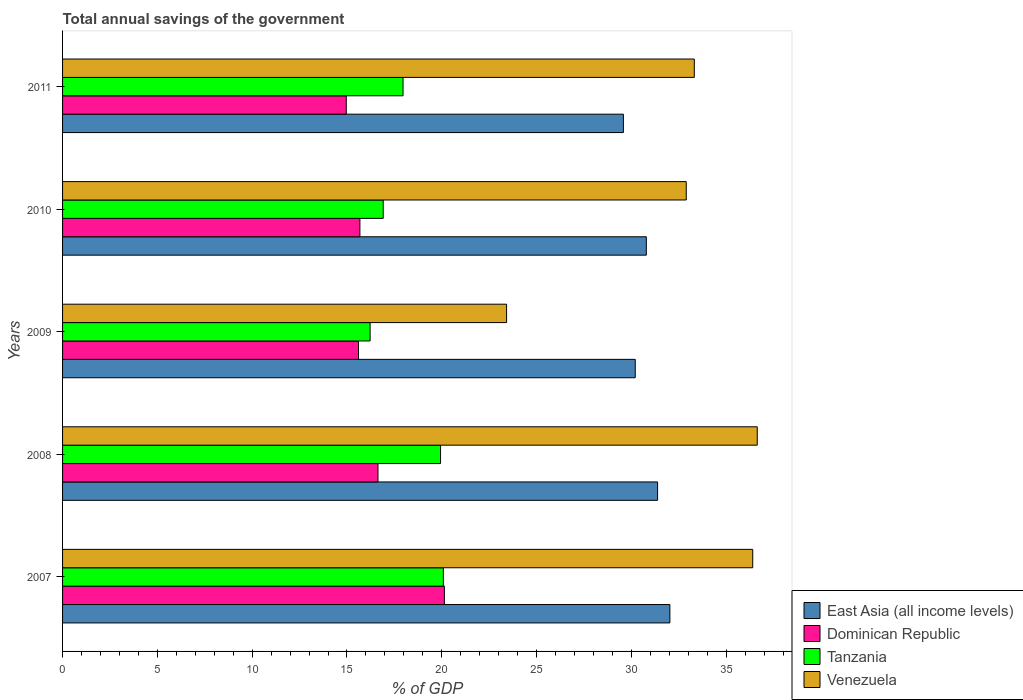How many different coloured bars are there?
Provide a succinct answer. 4. How many groups of bars are there?
Give a very brief answer. 5. Are the number of bars per tick equal to the number of legend labels?
Offer a very short reply. Yes. Are the number of bars on each tick of the Y-axis equal?
Your response must be concise. Yes. How many bars are there on the 3rd tick from the top?
Provide a succinct answer. 4. How many bars are there on the 3rd tick from the bottom?
Offer a terse response. 4. What is the total annual savings of the government in Venezuela in 2011?
Make the answer very short. 33.32. Across all years, what is the maximum total annual savings of the government in Venezuela?
Provide a short and direct response. 36.64. Across all years, what is the minimum total annual savings of the government in Venezuela?
Offer a very short reply. 23.42. In which year was the total annual savings of the government in Tanzania minimum?
Give a very brief answer. 2009. What is the total total annual savings of the government in Dominican Republic in the graph?
Make the answer very short. 83.03. What is the difference between the total annual savings of the government in Tanzania in 2007 and that in 2008?
Your answer should be compact. 0.15. What is the difference between the total annual savings of the government in Dominican Republic in 2010 and the total annual savings of the government in Tanzania in 2011?
Make the answer very short. -2.28. What is the average total annual savings of the government in Dominican Republic per year?
Make the answer very short. 16.61. In the year 2011, what is the difference between the total annual savings of the government in East Asia (all income levels) and total annual savings of the government in Dominican Republic?
Ensure brevity in your answer.  14.62. What is the ratio of the total annual savings of the government in Dominican Republic in 2008 to that in 2011?
Your answer should be very brief. 1.11. Is the difference between the total annual savings of the government in East Asia (all income levels) in 2007 and 2010 greater than the difference between the total annual savings of the government in Dominican Republic in 2007 and 2010?
Make the answer very short. No. What is the difference between the highest and the second highest total annual savings of the government in Venezuela?
Provide a short and direct response. 0.24. What is the difference between the highest and the lowest total annual savings of the government in Dominican Republic?
Offer a very short reply. 5.17. In how many years, is the total annual savings of the government in Tanzania greater than the average total annual savings of the government in Tanzania taken over all years?
Give a very brief answer. 2. Is it the case that in every year, the sum of the total annual savings of the government in Tanzania and total annual savings of the government in Dominican Republic is greater than the sum of total annual savings of the government in East Asia (all income levels) and total annual savings of the government in Venezuela?
Provide a succinct answer. No. What does the 2nd bar from the top in 2009 represents?
Offer a very short reply. Tanzania. What does the 2nd bar from the bottom in 2007 represents?
Offer a very short reply. Dominican Republic. Is it the case that in every year, the sum of the total annual savings of the government in East Asia (all income levels) and total annual savings of the government in Venezuela is greater than the total annual savings of the government in Dominican Republic?
Provide a short and direct response. Yes. Are all the bars in the graph horizontal?
Make the answer very short. Yes. What is the difference between two consecutive major ticks on the X-axis?
Your answer should be compact. 5. Are the values on the major ticks of X-axis written in scientific E-notation?
Provide a succinct answer. No. Where does the legend appear in the graph?
Give a very brief answer. Bottom right. What is the title of the graph?
Offer a very short reply. Total annual savings of the government. Does "Belize" appear as one of the legend labels in the graph?
Offer a terse response. No. What is the label or title of the X-axis?
Keep it short and to the point. % of GDP. What is the % of GDP in East Asia (all income levels) in 2007?
Offer a very short reply. 32.03. What is the % of GDP in Dominican Republic in 2007?
Your answer should be compact. 20.14. What is the % of GDP in Tanzania in 2007?
Your answer should be very brief. 20.08. What is the % of GDP of Venezuela in 2007?
Offer a terse response. 36.4. What is the % of GDP in East Asia (all income levels) in 2008?
Your answer should be very brief. 31.38. What is the % of GDP in Dominican Republic in 2008?
Provide a succinct answer. 16.64. What is the % of GDP in Tanzania in 2008?
Keep it short and to the point. 19.94. What is the % of GDP of Venezuela in 2008?
Your response must be concise. 36.64. What is the % of GDP in East Asia (all income levels) in 2009?
Keep it short and to the point. 30.21. What is the % of GDP in Dominican Republic in 2009?
Provide a short and direct response. 15.61. What is the % of GDP in Tanzania in 2009?
Your answer should be compact. 16.22. What is the % of GDP of Venezuela in 2009?
Your response must be concise. 23.42. What is the % of GDP in East Asia (all income levels) in 2010?
Provide a succinct answer. 30.79. What is the % of GDP of Dominican Republic in 2010?
Keep it short and to the point. 15.68. What is the % of GDP of Tanzania in 2010?
Ensure brevity in your answer.  16.91. What is the % of GDP of Venezuela in 2010?
Your answer should be very brief. 32.9. What is the % of GDP of East Asia (all income levels) in 2011?
Offer a terse response. 29.58. What is the % of GDP of Dominican Republic in 2011?
Offer a very short reply. 14.96. What is the % of GDP in Tanzania in 2011?
Keep it short and to the point. 17.96. What is the % of GDP of Venezuela in 2011?
Offer a very short reply. 33.32. Across all years, what is the maximum % of GDP in East Asia (all income levels)?
Offer a very short reply. 32.03. Across all years, what is the maximum % of GDP of Dominican Republic?
Offer a terse response. 20.14. Across all years, what is the maximum % of GDP in Tanzania?
Keep it short and to the point. 20.08. Across all years, what is the maximum % of GDP in Venezuela?
Your answer should be compact. 36.64. Across all years, what is the minimum % of GDP in East Asia (all income levels)?
Offer a very short reply. 29.58. Across all years, what is the minimum % of GDP of Dominican Republic?
Your answer should be compact. 14.96. Across all years, what is the minimum % of GDP of Tanzania?
Your response must be concise. 16.22. Across all years, what is the minimum % of GDP of Venezuela?
Provide a short and direct response. 23.42. What is the total % of GDP of East Asia (all income levels) in the graph?
Keep it short and to the point. 153.99. What is the total % of GDP in Dominican Republic in the graph?
Keep it short and to the point. 83.03. What is the total % of GDP in Tanzania in the graph?
Your answer should be very brief. 91.11. What is the total % of GDP of Venezuela in the graph?
Offer a terse response. 162.68. What is the difference between the % of GDP in East Asia (all income levels) in 2007 and that in 2008?
Your response must be concise. 0.65. What is the difference between the % of GDP in Dominican Republic in 2007 and that in 2008?
Provide a short and direct response. 3.5. What is the difference between the % of GDP of Tanzania in 2007 and that in 2008?
Provide a succinct answer. 0.15. What is the difference between the % of GDP of Venezuela in 2007 and that in 2008?
Offer a terse response. -0.24. What is the difference between the % of GDP in East Asia (all income levels) in 2007 and that in 2009?
Provide a succinct answer. 1.83. What is the difference between the % of GDP of Dominican Republic in 2007 and that in 2009?
Your response must be concise. 4.53. What is the difference between the % of GDP of Tanzania in 2007 and that in 2009?
Ensure brevity in your answer.  3.86. What is the difference between the % of GDP of Venezuela in 2007 and that in 2009?
Ensure brevity in your answer.  12.98. What is the difference between the % of GDP in East Asia (all income levels) in 2007 and that in 2010?
Keep it short and to the point. 1.24. What is the difference between the % of GDP of Dominican Republic in 2007 and that in 2010?
Keep it short and to the point. 4.46. What is the difference between the % of GDP of Tanzania in 2007 and that in 2010?
Your answer should be compact. 3.17. What is the difference between the % of GDP of Venezuela in 2007 and that in 2010?
Provide a short and direct response. 3.51. What is the difference between the % of GDP in East Asia (all income levels) in 2007 and that in 2011?
Make the answer very short. 2.45. What is the difference between the % of GDP of Dominican Republic in 2007 and that in 2011?
Make the answer very short. 5.17. What is the difference between the % of GDP of Tanzania in 2007 and that in 2011?
Provide a succinct answer. 2.13. What is the difference between the % of GDP of Venezuela in 2007 and that in 2011?
Your response must be concise. 3.08. What is the difference between the % of GDP in East Asia (all income levels) in 2008 and that in 2009?
Offer a very short reply. 1.18. What is the difference between the % of GDP of Dominican Republic in 2008 and that in 2009?
Provide a short and direct response. 1.03. What is the difference between the % of GDP in Tanzania in 2008 and that in 2009?
Keep it short and to the point. 3.71. What is the difference between the % of GDP in Venezuela in 2008 and that in 2009?
Your answer should be compact. 13.22. What is the difference between the % of GDP of East Asia (all income levels) in 2008 and that in 2010?
Make the answer very short. 0.59. What is the difference between the % of GDP of Dominican Republic in 2008 and that in 2010?
Give a very brief answer. 0.95. What is the difference between the % of GDP in Tanzania in 2008 and that in 2010?
Your answer should be very brief. 3.02. What is the difference between the % of GDP of Venezuela in 2008 and that in 2010?
Offer a terse response. 3.74. What is the difference between the % of GDP in East Asia (all income levels) in 2008 and that in 2011?
Make the answer very short. 1.8. What is the difference between the % of GDP of Dominican Republic in 2008 and that in 2011?
Offer a very short reply. 1.67. What is the difference between the % of GDP in Tanzania in 2008 and that in 2011?
Your response must be concise. 1.98. What is the difference between the % of GDP in Venezuela in 2008 and that in 2011?
Ensure brevity in your answer.  3.32. What is the difference between the % of GDP in East Asia (all income levels) in 2009 and that in 2010?
Offer a very short reply. -0.58. What is the difference between the % of GDP in Dominican Republic in 2009 and that in 2010?
Ensure brevity in your answer.  -0.07. What is the difference between the % of GDP in Tanzania in 2009 and that in 2010?
Provide a succinct answer. -0.69. What is the difference between the % of GDP of Venezuela in 2009 and that in 2010?
Your answer should be very brief. -9.48. What is the difference between the % of GDP in East Asia (all income levels) in 2009 and that in 2011?
Provide a short and direct response. 0.62. What is the difference between the % of GDP of Dominican Republic in 2009 and that in 2011?
Offer a terse response. 0.64. What is the difference between the % of GDP of Tanzania in 2009 and that in 2011?
Your answer should be compact. -1.74. What is the difference between the % of GDP of Venezuela in 2009 and that in 2011?
Offer a very short reply. -9.9. What is the difference between the % of GDP in East Asia (all income levels) in 2010 and that in 2011?
Your response must be concise. 1.21. What is the difference between the % of GDP of Dominican Republic in 2010 and that in 2011?
Offer a terse response. 0.72. What is the difference between the % of GDP in Tanzania in 2010 and that in 2011?
Provide a succinct answer. -1.05. What is the difference between the % of GDP in Venezuela in 2010 and that in 2011?
Offer a very short reply. -0.42. What is the difference between the % of GDP in East Asia (all income levels) in 2007 and the % of GDP in Dominican Republic in 2008?
Offer a very short reply. 15.4. What is the difference between the % of GDP in East Asia (all income levels) in 2007 and the % of GDP in Tanzania in 2008?
Offer a very short reply. 12.1. What is the difference between the % of GDP of East Asia (all income levels) in 2007 and the % of GDP of Venezuela in 2008?
Provide a succinct answer. -4.61. What is the difference between the % of GDP in Dominican Republic in 2007 and the % of GDP in Tanzania in 2008?
Ensure brevity in your answer.  0.2. What is the difference between the % of GDP in Dominican Republic in 2007 and the % of GDP in Venezuela in 2008?
Provide a short and direct response. -16.5. What is the difference between the % of GDP of Tanzania in 2007 and the % of GDP of Venezuela in 2008?
Offer a terse response. -16.56. What is the difference between the % of GDP in East Asia (all income levels) in 2007 and the % of GDP in Dominican Republic in 2009?
Offer a very short reply. 16.42. What is the difference between the % of GDP in East Asia (all income levels) in 2007 and the % of GDP in Tanzania in 2009?
Ensure brevity in your answer.  15.81. What is the difference between the % of GDP of East Asia (all income levels) in 2007 and the % of GDP of Venezuela in 2009?
Ensure brevity in your answer.  8.61. What is the difference between the % of GDP in Dominican Republic in 2007 and the % of GDP in Tanzania in 2009?
Keep it short and to the point. 3.92. What is the difference between the % of GDP in Dominican Republic in 2007 and the % of GDP in Venezuela in 2009?
Your answer should be very brief. -3.28. What is the difference between the % of GDP of Tanzania in 2007 and the % of GDP of Venezuela in 2009?
Your response must be concise. -3.33. What is the difference between the % of GDP of East Asia (all income levels) in 2007 and the % of GDP of Dominican Republic in 2010?
Ensure brevity in your answer.  16.35. What is the difference between the % of GDP of East Asia (all income levels) in 2007 and the % of GDP of Tanzania in 2010?
Offer a terse response. 15.12. What is the difference between the % of GDP in East Asia (all income levels) in 2007 and the % of GDP in Venezuela in 2010?
Your answer should be compact. -0.86. What is the difference between the % of GDP of Dominican Republic in 2007 and the % of GDP of Tanzania in 2010?
Make the answer very short. 3.23. What is the difference between the % of GDP in Dominican Republic in 2007 and the % of GDP in Venezuela in 2010?
Offer a terse response. -12.76. What is the difference between the % of GDP of Tanzania in 2007 and the % of GDP of Venezuela in 2010?
Your answer should be very brief. -12.81. What is the difference between the % of GDP of East Asia (all income levels) in 2007 and the % of GDP of Dominican Republic in 2011?
Provide a succinct answer. 17.07. What is the difference between the % of GDP of East Asia (all income levels) in 2007 and the % of GDP of Tanzania in 2011?
Keep it short and to the point. 14.07. What is the difference between the % of GDP of East Asia (all income levels) in 2007 and the % of GDP of Venezuela in 2011?
Your response must be concise. -1.29. What is the difference between the % of GDP in Dominican Republic in 2007 and the % of GDP in Tanzania in 2011?
Offer a very short reply. 2.18. What is the difference between the % of GDP in Dominican Republic in 2007 and the % of GDP in Venezuela in 2011?
Make the answer very short. -13.18. What is the difference between the % of GDP in Tanzania in 2007 and the % of GDP in Venezuela in 2011?
Give a very brief answer. -13.24. What is the difference between the % of GDP in East Asia (all income levels) in 2008 and the % of GDP in Dominican Republic in 2009?
Offer a terse response. 15.78. What is the difference between the % of GDP in East Asia (all income levels) in 2008 and the % of GDP in Tanzania in 2009?
Ensure brevity in your answer.  15.16. What is the difference between the % of GDP in East Asia (all income levels) in 2008 and the % of GDP in Venezuela in 2009?
Your response must be concise. 7.96. What is the difference between the % of GDP in Dominican Republic in 2008 and the % of GDP in Tanzania in 2009?
Your response must be concise. 0.42. What is the difference between the % of GDP of Dominican Republic in 2008 and the % of GDP of Venezuela in 2009?
Your answer should be very brief. -6.78. What is the difference between the % of GDP of Tanzania in 2008 and the % of GDP of Venezuela in 2009?
Ensure brevity in your answer.  -3.48. What is the difference between the % of GDP in East Asia (all income levels) in 2008 and the % of GDP in Dominican Republic in 2010?
Offer a terse response. 15.7. What is the difference between the % of GDP in East Asia (all income levels) in 2008 and the % of GDP in Tanzania in 2010?
Provide a succinct answer. 14.47. What is the difference between the % of GDP in East Asia (all income levels) in 2008 and the % of GDP in Venezuela in 2010?
Ensure brevity in your answer.  -1.51. What is the difference between the % of GDP of Dominican Republic in 2008 and the % of GDP of Tanzania in 2010?
Ensure brevity in your answer.  -0.28. What is the difference between the % of GDP in Dominican Republic in 2008 and the % of GDP in Venezuela in 2010?
Your answer should be very brief. -16.26. What is the difference between the % of GDP of Tanzania in 2008 and the % of GDP of Venezuela in 2010?
Give a very brief answer. -12.96. What is the difference between the % of GDP of East Asia (all income levels) in 2008 and the % of GDP of Dominican Republic in 2011?
Give a very brief answer. 16.42. What is the difference between the % of GDP of East Asia (all income levels) in 2008 and the % of GDP of Tanzania in 2011?
Your answer should be compact. 13.42. What is the difference between the % of GDP in East Asia (all income levels) in 2008 and the % of GDP in Venezuela in 2011?
Keep it short and to the point. -1.94. What is the difference between the % of GDP of Dominican Republic in 2008 and the % of GDP of Tanzania in 2011?
Offer a very short reply. -1.32. What is the difference between the % of GDP in Dominican Republic in 2008 and the % of GDP in Venezuela in 2011?
Provide a succinct answer. -16.68. What is the difference between the % of GDP in Tanzania in 2008 and the % of GDP in Venezuela in 2011?
Your response must be concise. -13.38. What is the difference between the % of GDP in East Asia (all income levels) in 2009 and the % of GDP in Dominican Republic in 2010?
Your answer should be very brief. 14.52. What is the difference between the % of GDP of East Asia (all income levels) in 2009 and the % of GDP of Tanzania in 2010?
Your response must be concise. 13.29. What is the difference between the % of GDP in East Asia (all income levels) in 2009 and the % of GDP in Venezuela in 2010?
Provide a succinct answer. -2.69. What is the difference between the % of GDP in Dominican Republic in 2009 and the % of GDP in Tanzania in 2010?
Provide a succinct answer. -1.3. What is the difference between the % of GDP in Dominican Republic in 2009 and the % of GDP in Venezuela in 2010?
Give a very brief answer. -17.29. What is the difference between the % of GDP in Tanzania in 2009 and the % of GDP in Venezuela in 2010?
Offer a terse response. -16.67. What is the difference between the % of GDP in East Asia (all income levels) in 2009 and the % of GDP in Dominican Republic in 2011?
Your answer should be very brief. 15.24. What is the difference between the % of GDP in East Asia (all income levels) in 2009 and the % of GDP in Tanzania in 2011?
Your answer should be compact. 12.25. What is the difference between the % of GDP of East Asia (all income levels) in 2009 and the % of GDP of Venezuela in 2011?
Make the answer very short. -3.12. What is the difference between the % of GDP in Dominican Republic in 2009 and the % of GDP in Tanzania in 2011?
Ensure brevity in your answer.  -2.35. What is the difference between the % of GDP of Dominican Republic in 2009 and the % of GDP of Venezuela in 2011?
Provide a succinct answer. -17.71. What is the difference between the % of GDP of Tanzania in 2009 and the % of GDP of Venezuela in 2011?
Provide a short and direct response. -17.1. What is the difference between the % of GDP of East Asia (all income levels) in 2010 and the % of GDP of Dominican Republic in 2011?
Provide a short and direct response. 15.83. What is the difference between the % of GDP in East Asia (all income levels) in 2010 and the % of GDP in Tanzania in 2011?
Offer a terse response. 12.83. What is the difference between the % of GDP of East Asia (all income levels) in 2010 and the % of GDP of Venezuela in 2011?
Ensure brevity in your answer.  -2.53. What is the difference between the % of GDP of Dominican Republic in 2010 and the % of GDP of Tanzania in 2011?
Your response must be concise. -2.28. What is the difference between the % of GDP in Dominican Republic in 2010 and the % of GDP in Venezuela in 2011?
Make the answer very short. -17.64. What is the difference between the % of GDP in Tanzania in 2010 and the % of GDP in Venezuela in 2011?
Your answer should be very brief. -16.41. What is the average % of GDP of East Asia (all income levels) per year?
Make the answer very short. 30.8. What is the average % of GDP of Dominican Republic per year?
Offer a terse response. 16.61. What is the average % of GDP of Tanzania per year?
Keep it short and to the point. 18.22. What is the average % of GDP in Venezuela per year?
Your answer should be very brief. 32.54. In the year 2007, what is the difference between the % of GDP of East Asia (all income levels) and % of GDP of Dominican Republic?
Provide a succinct answer. 11.89. In the year 2007, what is the difference between the % of GDP of East Asia (all income levels) and % of GDP of Tanzania?
Offer a very short reply. 11.95. In the year 2007, what is the difference between the % of GDP in East Asia (all income levels) and % of GDP in Venezuela?
Give a very brief answer. -4.37. In the year 2007, what is the difference between the % of GDP in Dominican Republic and % of GDP in Tanzania?
Keep it short and to the point. 0.05. In the year 2007, what is the difference between the % of GDP in Dominican Republic and % of GDP in Venezuela?
Offer a terse response. -16.26. In the year 2007, what is the difference between the % of GDP of Tanzania and % of GDP of Venezuela?
Your answer should be very brief. -16.32. In the year 2008, what is the difference between the % of GDP of East Asia (all income levels) and % of GDP of Dominican Republic?
Offer a terse response. 14.75. In the year 2008, what is the difference between the % of GDP of East Asia (all income levels) and % of GDP of Tanzania?
Make the answer very short. 11.45. In the year 2008, what is the difference between the % of GDP of East Asia (all income levels) and % of GDP of Venezuela?
Your answer should be compact. -5.26. In the year 2008, what is the difference between the % of GDP of Dominican Republic and % of GDP of Tanzania?
Keep it short and to the point. -3.3. In the year 2008, what is the difference between the % of GDP of Dominican Republic and % of GDP of Venezuela?
Provide a succinct answer. -20. In the year 2008, what is the difference between the % of GDP in Tanzania and % of GDP in Venezuela?
Provide a short and direct response. -16.7. In the year 2009, what is the difference between the % of GDP of East Asia (all income levels) and % of GDP of Dominican Republic?
Your answer should be very brief. 14.6. In the year 2009, what is the difference between the % of GDP of East Asia (all income levels) and % of GDP of Tanzania?
Keep it short and to the point. 13.98. In the year 2009, what is the difference between the % of GDP of East Asia (all income levels) and % of GDP of Venezuela?
Your answer should be very brief. 6.79. In the year 2009, what is the difference between the % of GDP of Dominican Republic and % of GDP of Tanzania?
Keep it short and to the point. -0.61. In the year 2009, what is the difference between the % of GDP of Dominican Republic and % of GDP of Venezuela?
Ensure brevity in your answer.  -7.81. In the year 2009, what is the difference between the % of GDP in Tanzania and % of GDP in Venezuela?
Provide a short and direct response. -7.2. In the year 2010, what is the difference between the % of GDP in East Asia (all income levels) and % of GDP in Dominican Republic?
Your response must be concise. 15.11. In the year 2010, what is the difference between the % of GDP of East Asia (all income levels) and % of GDP of Tanzania?
Make the answer very short. 13.88. In the year 2010, what is the difference between the % of GDP of East Asia (all income levels) and % of GDP of Venezuela?
Your answer should be very brief. -2.11. In the year 2010, what is the difference between the % of GDP in Dominican Republic and % of GDP in Tanzania?
Ensure brevity in your answer.  -1.23. In the year 2010, what is the difference between the % of GDP of Dominican Republic and % of GDP of Venezuela?
Offer a very short reply. -17.21. In the year 2010, what is the difference between the % of GDP in Tanzania and % of GDP in Venezuela?
Provide a short and direct response. -15.98. In the year 2011, what is the difference between the % of GDP of East Asia (all income levels) and % of GDP of Dominican Republic?
Your answer should be compact. 14.62. In the year 2011, what is the difference between the % of GDP in East Asia (all income levels) and % of GDP in Tanzania?
Offer a terse response. 11.62. In the year 2011, what is the difference between the % of GDP of East Asia (all income levels) and % of GDP of Venezuela?
Make the answer very short. -3.74. In the year 2011, what is the difference between the % of GDP in Dominican Republic and % of GDP in Tanzania?
Your answer should be compact. -2.99. In the year 2011, what is the difference between the % of GDP in Dominican Republic and % of GDP in Venezuela?
Offer a very short reply. -18.36. In the year 2011, what is the difference between the % of GDP in Tanzania and % of GDP in Venezuela?
Keep it short and to the point. -15.36. What is the ratio of the % of GDP in East Asia (all income levels) in 2007 to that in 2008?
Provide a succinct answer. 1.02. What is the ratio of the % of GDP in Dominican Republic in 2007 to that in 2008?
Provide a short and direct response. 1.21. What is the ratio of the % of GDP in Tanzania in 2007 to that in 2008?
Keep it short and to the point. 1.01. What is the ratio of the % of GDP in Venezuela in 2007 to that in 2008?
Your answer should be very brief. 0.99. What is the ratio of the % of GDP in East Asia (all income levels) in 2007 to that in 2009?
Your response must be concise. 1.06. What is the ratio of the % of GDP in Dominican Republic in 2007 to that in 2009?
Give a very brief answer. 1.29. What is the ratio of the % of GDP of Tanzania in 2007 to that in 2009?
Provide a succinct answer. 1.24. What is the ratio of the % of GDP in Venezuela in 2007 to that in 2009?
Your response must be concise. 1.55. What is the ratio of the % of GDP in East Asia (all income levels) in 2007 to that in 2010?
Give a very brief answer. 1.04. What is the ratio of the % of GDP of Dominican Republic in 2007 to that in 2010?
Your response must be concise. 1.28. What is the ratio of the % of GDP in Tanzania in 2007 to that in 2010?
Your answer should be compact. 1.19. What is the ratio of the % of GDP in Venezuela in 2007 to that in 2010?
Give a very brief answer. 1.11. What is the ratio of the % of GDP in East Asia (all income levels) in 2007 to that in 2011?
Offer a very short reply. 1.08. What is the ratio of the % of GDP of Dominican Republic in 2007 to that in 2011?
Ensure brevity in your answer.  1.35. What is the ratio of the % of GDP of Tanzania in 2007 to that in 2011?
Provide a succinct answer. 1.12. What is the ratio of the % of GDP of Venezuela in 2007 to that in 2011?
Your answer should be compact. 1.09. What is the ratio of the % of GDP of East Asia (all income levels) in 2008 to that in 2009?
Provide a succinct answer. 1.04. What is the ratio of the % of GDP in Dominican Republic in 2008 to that in 2009?
Your answer should be compact. 1.07. What is the ratio of the % of GDP in Tanzania in 2008 to that in 2009?
Keep it short and to the point. 1.23. What is the ratio of the % of GDP of Venezuela in 2008 to that in 2009?
Your answer should be very brief. 1.56. What is the ratio of the % of GDP in East Asia (all income levels) in 2008 to that in 2010?
Provide a short and direct response. 1.02. What is the ratio of the % of GDP of Dominican Republic in 2008 to that in 2010?
Ensure brevity in your answer.  1.06. What is the ratio of the % of GDP in Tanzania in 2008 to that in 2010?
Your answer should be very brief. 1.18. What is the ratio of the % of GDP in Venezuela in 2008 to that in 2010?
Your answer should be compact. 1.11. What is the ratio of the % of GDP in East Asia (all income levels) in 2008 to that in 2011?
Your answer should be compact. 1.06. What is the ratio of the % of GDP in Dominican Republic in 2008 to that in 2011?
Your answer should be compact. 1.11. What is the ratio of the % of GDP of Tanzania in 2008 to that in 2011?
Your answer should be very brief. 1.11. What is the ratio of the % of GDP in Venezuela in 2008 to that in 2011?
Your answer should be compact. 1.1. What is the ratio of the % of GDP of East Asia (all income levels) in 2009 to that in 2010?
Offer a terse response. 0.98. What is the ratio of the % of GDP in Dominican Republic in 2009 to that in 2010?
Ensure brevity in your answer.  1. What is the ratio of the % of GDP in Tanzania in 2009 to that in 2010?
Provide a short and direct response. 0.96. What is the ratio of the % of GDP of Venezuela in 2009 to that in 2010?
Your answer should be very brief. 0.71. What is the ratio of the % of GDP in East Asia (all income levels) in 2009 to that in 2011?
Make the answer very short. 1.02. What is the ratio of the % of GDP of Dominican Republic in 2009 to that in 2011?
Give a very brief answer. 1.04. What is the ratio of the % of GDP of Tanzania in 2009 to that in 2011?
Keep it short and to the point. 0.9. What is the ratio of the % of GDP in Venezuela in 2009 to that in 2011?
Provide a succinct answer. 0.7. What is the ratio of the % of GDP in East Asia (all income levels) in 2010 to that in 2011?
Offer a terse response. 1.04. What is the ratio of the % of GDP in Dominican Republic in 2010 to that in 2011?
Your response must be concise. 1.05. What is the ratio of the % of GDP of Tanzania in 2010 to that in 2011?
Provide a short and direct response. 0.94. What is the ratio of the % of GDP in Venezuela in 2010 to that in 2011?
Your answer should be very brief. 0.99. What is the difference between the highest and the second highest % of GDP of East Asia (all income levels)?
Your answer should be compact. 0.65. What is the difference between the highest and the second highest % of GDP in Dominican Republic?
Ensure brevity in your answer.  3.5. What is the difference between the highest and the second highest % of GDP in Tanzania?
Your answer should be very brief. 0.15. What is the difference between the highest and the second highest % of GDP of Venezuela?
Offer a terse response. 0.24. What is the difference between the highest and the lowest % of GDP of East Asia (all income levels)?
Give a very brief answer. 2.45. What is the difference between the highest and the lowest % of GDP of Dominican Republic?
Provide a short and direct response. 5.17. What is the difference between the highest and the lowest % of GDP in Tanzania?
Make the answer very short. 3.86. What is the difference between the highest and the lowest % of GDP in Venezuela?
Give a very brief answer. 13.22. 